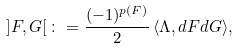Convert formula to latex. <formula><loc_0><loc_0><loc_500><loc_500>\left ] F , G \right [ \colon = \frac { ( - 1 ) ^ { p ( F ) } } { 2 } \, \langle \Lambda , d F d G \rangle ,</formula> 